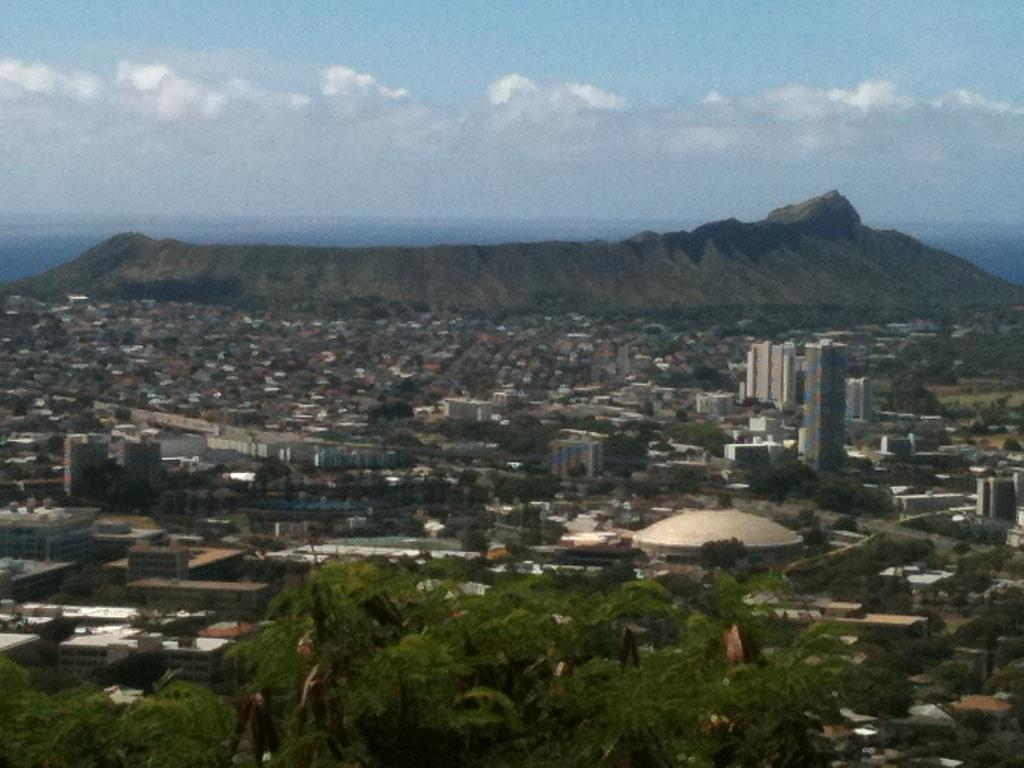What type of structures can be seen in the image? There are many buildings in the image. What other natural elements are present in the image? There are trees in the image. What can be seen in the distance in the background of the image? There is a hill in the background of the image. What is visible above the buildings and trees in the image? The sky is visible in the image. What can be observed in the sky in the image? Clouds are present in the sky. Where is the hen located in the image? There is no hen present in the image. What is the pail used for in the image? There is no pail present in the image. 